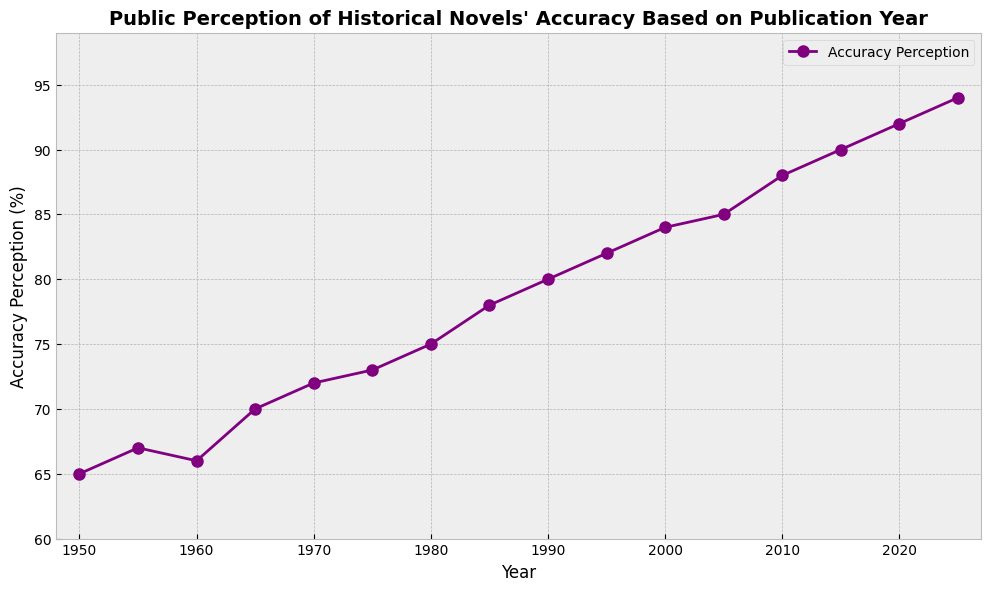Which year saw the highest public perception of historical novels' accuracy? By examining the figure, we see that the perception of accuracy increases over time. The highest value is at the last point on the graph, corresponding to the year 2025.
Answer: 2025 What is the difference in accuracy perception between 1965 and 1985? Looking at the accuracy perception values, we note they are 70% for 1965 and 78% for 1985. The difference is calculated as 78 - 70.
Answer: 8% During which five-year period did the accuracy perception increase the most? By analyzing the plot's slope, the sharpest increase can be seen between 2010 and 2015 where the values go from 88% to 90%, an increase of 2%, but the same increment is noted from 2020 to 2025. Multiple periods had increments tied in these intervals.
Answer: 2010-2015 or 2020-2025 What is the accuracy perception value's median between 1950 and 2025? There are 16 data points. Arranging them in order, the middle two values are (75 + 78)/2. Therefore, the median is calculated as (75 + 78)/2 = 76.5.
Answer: 76.5% How does the public perception of historical novels' accuracy in 2000 compare to 1970? The figure shows 2000 having an accuracy perception of 84% and 1970 having 72%. By comparing these two values, 2000 is higher.
Answer: 2000 is higher Between which consecutive pairs of years, 1950 to 1955 and 2005 to 2010, was the increase in the perception of accuracy higher? From 1950 to 1955, the increase is from 65% to 67%, which is an increase of 2%. From 2005 to 2010, the increase is from 85% to 88%, an increase of 3%. Therefore, the latter increase is higher.
Answer: 2005 to 2010 What was the average public perception of accuracy for the decades 1980, 1990, and 2000? From the figure, the values are 1980=75%, 1990=80%, 2000=84%. The average is (75 + 80 + 84)/3 = 79.67%.
Answer: 79.67% What color is used for the line representing accuracy perception in the plot? By examining the visual attributes of the line in the plot, it’s clear that the line color used is purple.
Answer: Purple What is the minimum accuracy perception value between 1950 and 2025, and in which year does it occur? By looking at the plot from 1950 to 2025, the lowest value is observed at 1950, which is 65%.
Answer: 1950, 65% Which year shows the first perceptible upward trend in the accuracy perception beyond 70%? Noticing the values, the first time it exceeds 70% is between 1970 (72%) and 1975 (73%).
Answer: 1970 